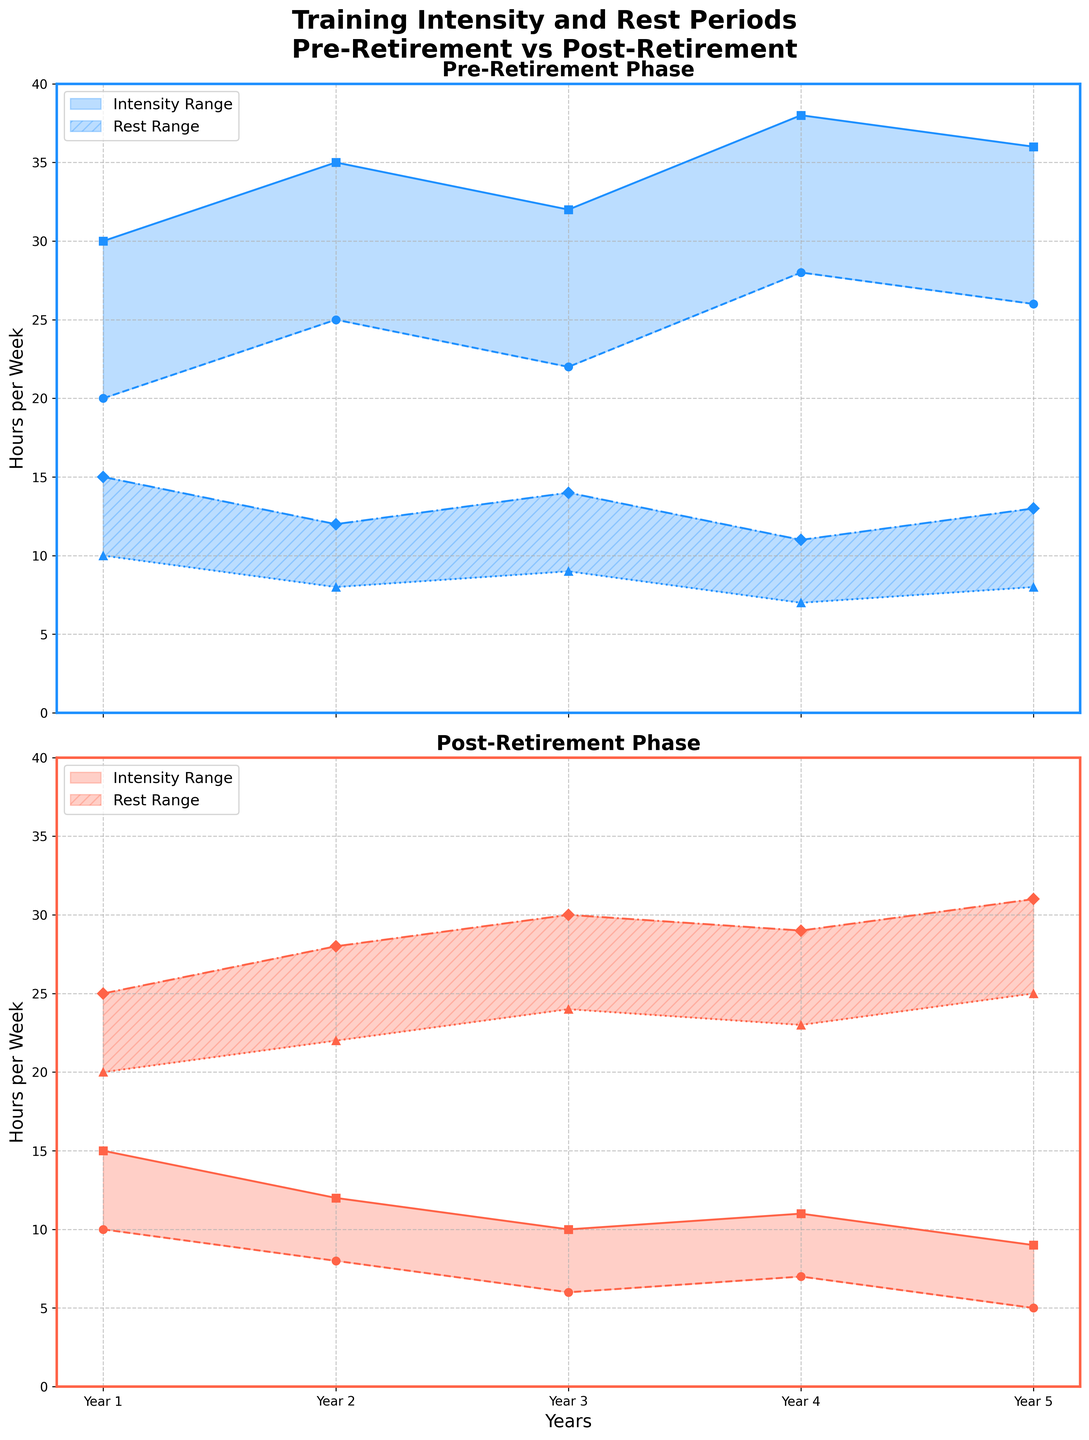What is the title of the figure? The title of the figure can usually be found at the top center of the plot. For this particular plot, it is displayed in bold and is meant to give a general idea of what the data represents.
Answer: "Training Intensity and Rest Periods Pre-Retirement vs Post-Retirement" What are the two main phases compared in this figure? By looking at the subplots, it is evident that the figure is split into two separate sections, each comparing different phases of training. The labels above each subplot provide this information.
Answer: Pre-Retirement and Post-Retirement How many years are shown for each phase? By examining the x-axis of each subplot, which displays the timeline for the phases, you can count the number of distinct years represented.
Answer: 5 years Which phase shows a higher minimum training intensity in Year 3? By comparing the minimum intensity line for Year 3 in both subplots, you can determine which phase has the higher value.
Answer: Pre-Retirement What is the range of rest periods during Year 2 of the Post-Retirement phase? The rest period range for any given year can be identified by the shaded area and the corresponding line markers on the subplot. For Post-Retirement Year 2, look at the data points.
Answer: 22 to 28 hours/week In which year is the maximum training intensity highest during the Pre-Retirement phase? Refer to the maximum intensity line in the Pre-Retirement subplot and compare the values across all years to find the highest point.
Answer: Year 4 How does the average minimum rest period change from Pre-Retirement to Post-Retirement Phase? First, calculate the average minimum rest period for each phase by adding the minimum rest period values for all years and then dividing by the number of years. Then compare the averages between the two phases.
Answer: Decreases from 8.4 hours/week to 22.8 hours/week Compare the trend in the maximum rest period between Year 1 and Year 5 for the Post-Retirement phase. By following the maximum rest period line in the Post-Retirement subplot from Year 1 to Year 5, you can observe whether it increases, decreases, or remains constant.
Answer: Increases from 25 to 31 hours/week What pattern do you observe in the minimum training intensity from Year 1 to Year 5 in the Post-Retirement phase? By plotting the points for minimum training intensity in the Post-Retirement subplot, you can observe the trend or pattern across the years.
Answer: Decreases from 10 to 5 hours/week 